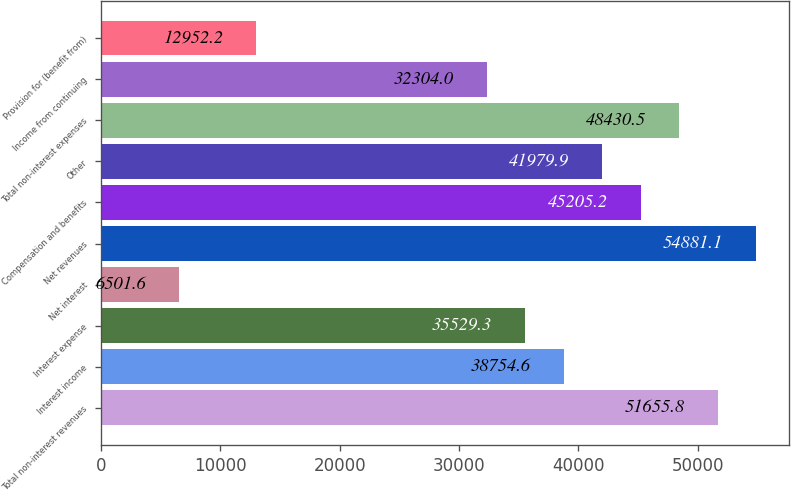<chart> <loc_0><loc_0><loc_500><loc_500><bar_chart><fcel>Total non-interest revenues<fcel>Interest income<fcel>Interest expense<fcel>Net interest<fcel>Net revenues<fcel>Compensation and benefits<fcel>Other<fcel>Total non-interest expenses<fcel>Income from continuing<fcel>Provision for (benefit from)<nl><fcel>51655.8<fcel>38754.6<fcel>35529.3<fcel>6501.6<fcel>54881.1<fcel>45205.2<fcel>41979.9<fcel>48430.5<fcel>32304<fcel>12952.2<nl></chart> 